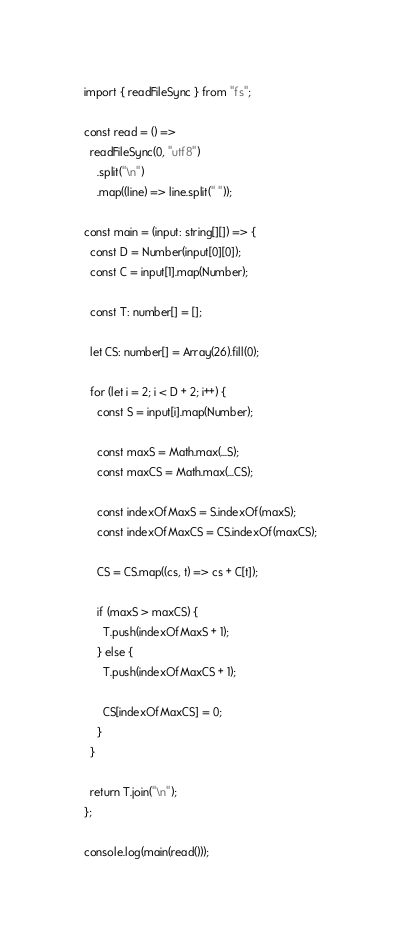Convert code to text. <code><loc_0><loc_0><loc_500><loc_500><_TypeScript_>import { readFileSync } from "fs";

const read = () =>
  readFileSync(0, "utf8")
    .split("\n")
    .map((line) => line.split(" "));

const main = (input: string[][]) => {
  const D = Number(input[0][0]);
  const C = input[1].map(Number);

  const T: number[] = [];

  let CS: number[] = Array(26).fill(0);

  for (let i = 2; i < D + 2; i++) {
    const S = input[i].map(Number);

    const maxS = Math.max(...S);
    const maxCS = Math.max(...CS);

    const indexOfMaxS = S.indexOf(maxS);
    const indexOfMaxCS = CS.indexOf(maxCS);

    CS = CS.map((cs, t) => cs + C[t]);

    if (maxS > maxCS) {
      T.push(indexOfMaxS + 1);
    } else {
      T.push(indexOfMaxCS + 1);

      CS[indexOfMaxCS] = 0;
    }
  }

  return T.join("\n");
};

console.log(main(read()));
</code> 